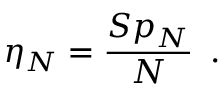<formula> <loc_0><loc_0><loc_500><loc_500>\eta _ { N } = \frac { { S p } _ { N } } { N } \, .</formula> 